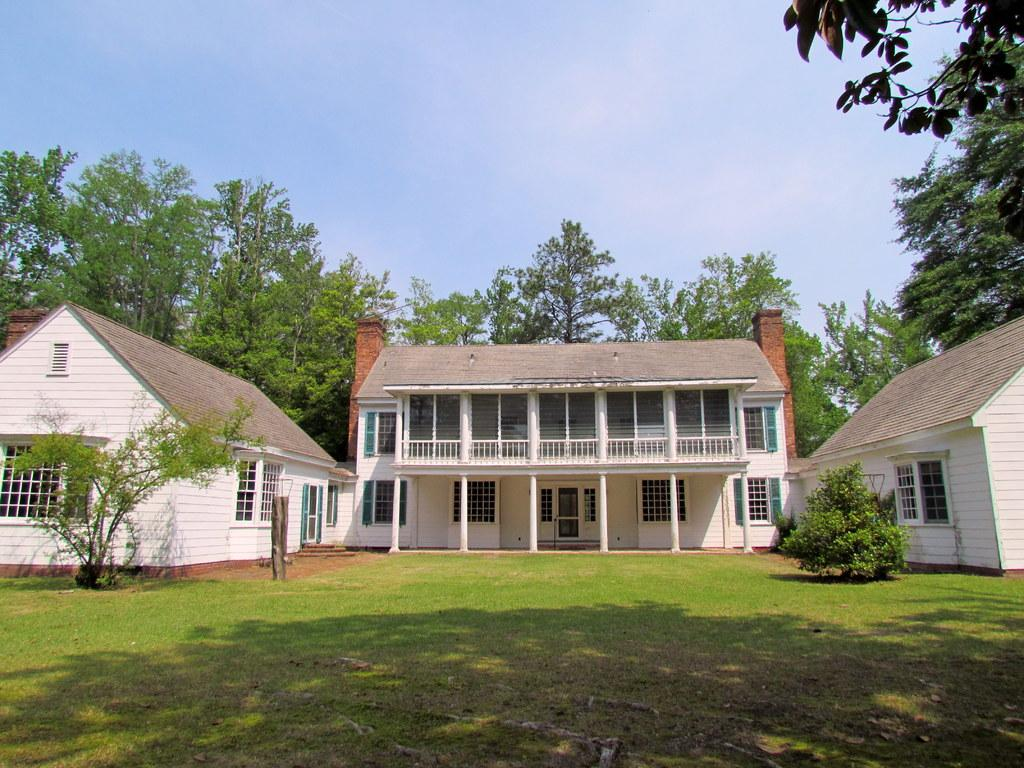What can be seen at the top of the image? The sky is visible in the image. What is the weather like on the day the image was taken? It appears to be a sunny day. What type of structures are present in the image? There are houses in the image. What type of vegetation can be seen in the image? Trees and plants are present in the image. What is visible at the bottom portion of the image? Grass is visible at the bottom portion of the image. What part of the houses can be seen in the image? Windows are visible in the image. What type of beef is being cooked on the dock in the image? There is no dock or beef present in the image. 